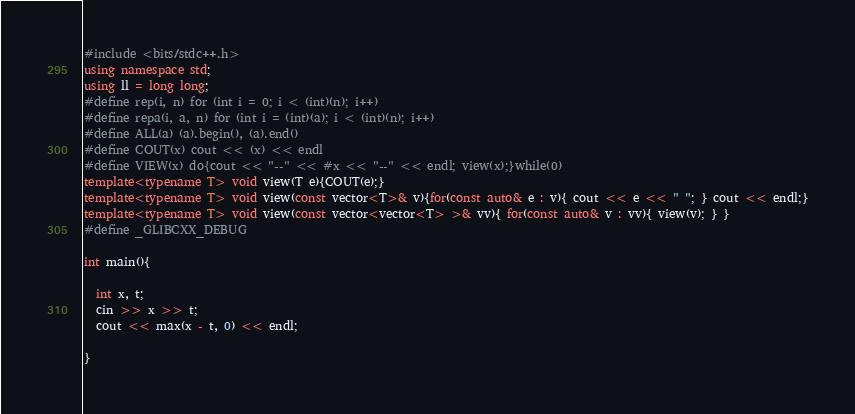<code> <loc_0><loc_0><loc_500><loc_500><_C++_>#include <bits/stdc++.h>
using namespace std;
using ll = long long;
#define rep(i, n) for (int i = 0; i < (int)(n); i++)
#define repa(i, a, n) for (int i = (int)(a); i < (int)(n); i++)
#define ALL(a) (a).begin(), (a).end()
#define COUT(x) cout << (x) << endl
#define VIEW(x) do{cout << "--" << #x << "--" << endl; view(x);}while(0)
template<typename T> void view(T e){COUT(e);}
template<typename T> void view(const vector<T>& v){for(const auto& e : v){ cout << e << " "; } cout << endl;}
template<typename T> void view(const vector<vector<T> >& vv){ for(const auto& v : vv){ view(v); } }
#define _GLIBCXX_DEBUG

int main(){
  
  int x, t;
  cin >> x >> t;
  cout << max(x - t, 0) << endl;

}</code> 